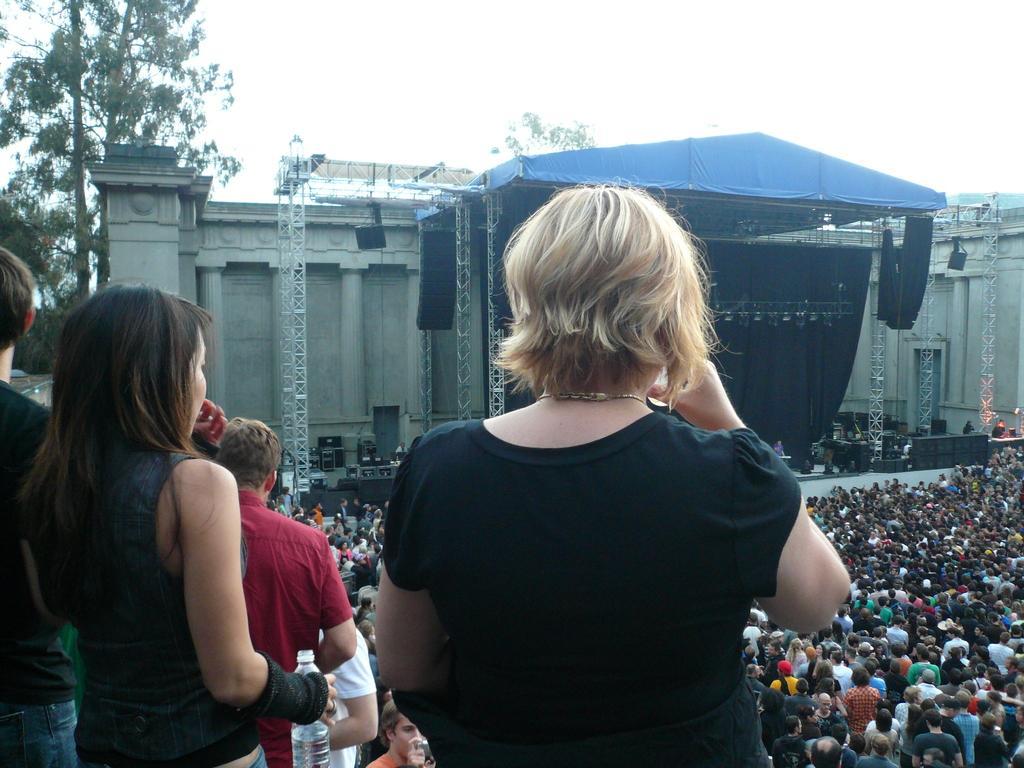Describe this image in one or two sentences. This image is taken outdoors. On the left side of the image there is a tree and a few people are standing on the floor. In the middle of the image a woman is standing on the floor and drinking water in a glass. At the top of the image there is a sky. In the background there is a building and there is a stage with a roof and iron bars, and there are many people standing on the ground. 